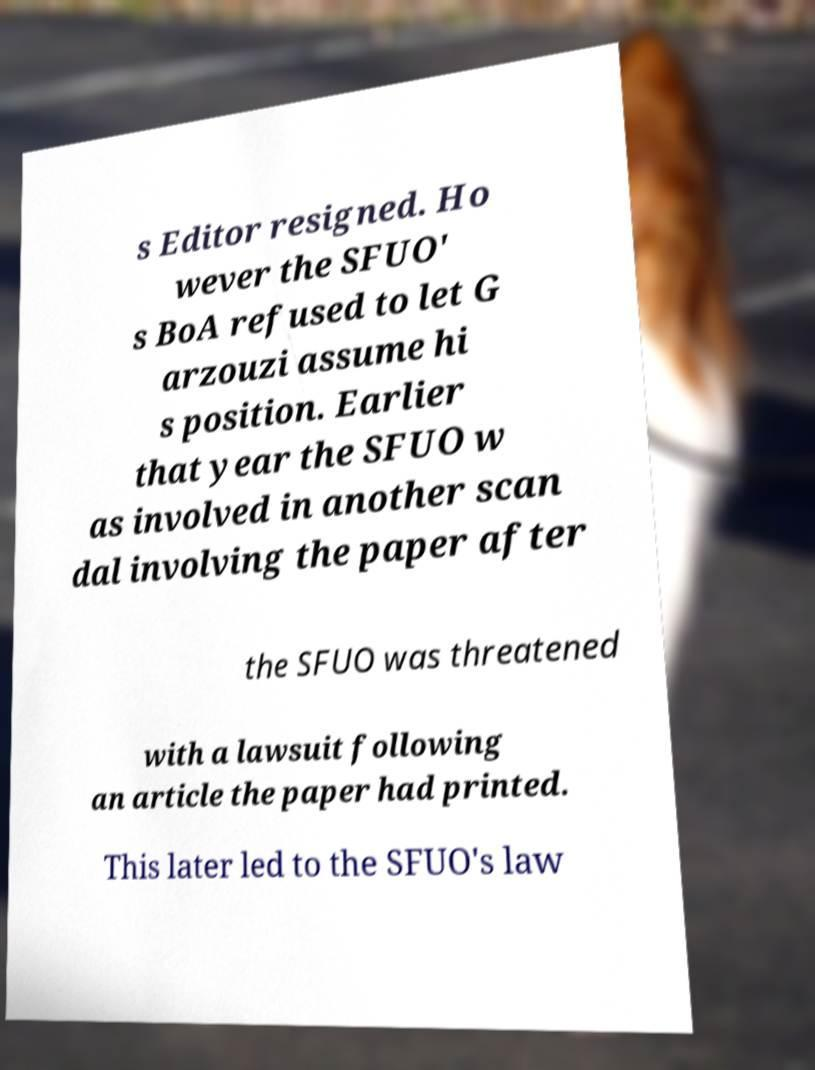What messages or text are displayed in this image? I need them in a readable, typed format. s Editor resigned. Ho wever the SFUO' s BoA refused to let G arzouzi assume hi s position. Earlier that year the SFUO w as involved in another scan dal involving the paper after the SFUO was threatened with a lawsuit following an article the paper had printed. This later led to the SFUO's law 